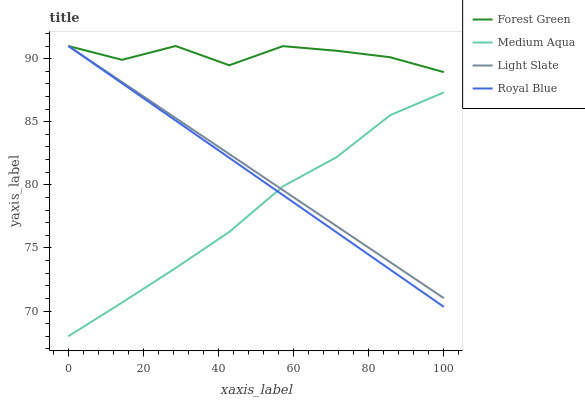Does Medium Aqua have the minimum area under the curve?
Answer yes or no. Yes. Does Forest Green have the maximum area under the curve?
Answer yes or no. Yes. Does Royal Blue have the minimum area under the curve?
Answer yes or no. No. Does Royal Blue have the maximum area under the curve?
Answer yes or no. No. Is Light Slate the smoothest?
Answer yes or no. Yes. Is Forest Green the roughest?
Answer yes or no. Yes. Is Royal Blue the smoothest?
Answer yes or no. No. Is Royal Blue the roughest?
Answer yes or no. No. Does Medium Aqua have the lowest value?
Answer yes or no. Yes. Does Royal Blue have the lowest value?
Answer yes or no. No. Does Forest Green have the highest value?
Answer yes or no. Yes. Does Medium Aqua have the highest value?
Answer yes or no. No. Is Medium Aqua less than Forest Green?
Answer yes or no. Yes. Is Forest Green greater than Medium Aqua?
Answer yes or no. Yes. Does Royal Blue intersect Medium Aqua?
Answer yes or no. Yes. Is Royal Blue less than Medium Aqua?
Answer yes or no. No. Is Royal Blue greater than Medium Aqua?
Answer yes or no. No. Does Medium Aqua intersect Forest Green?
Answer yes or no. No. 